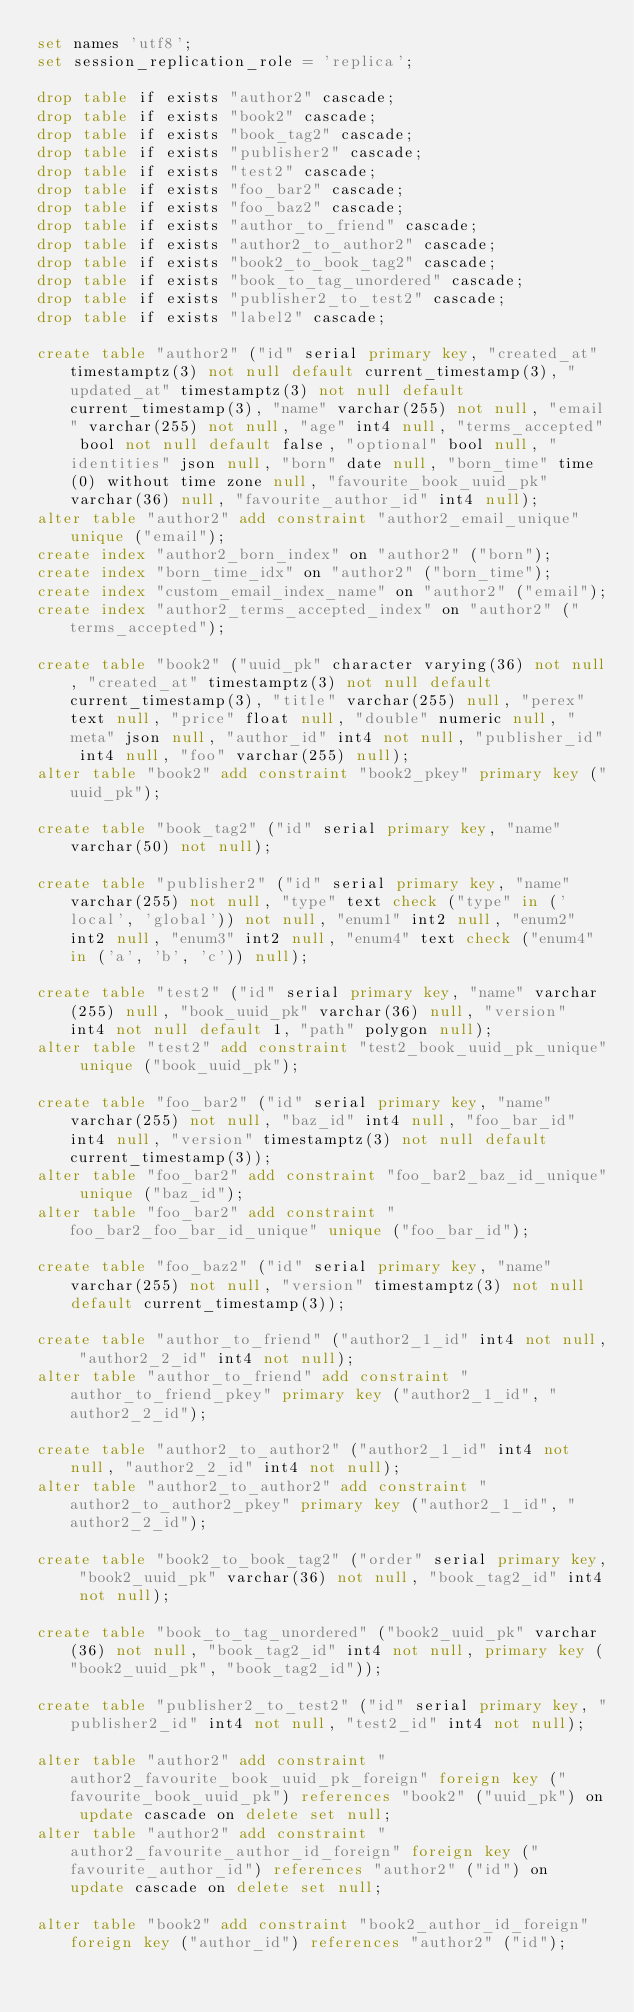<code> <loc_0><loc_0><loc_500><loc_500><_SQL_>set names 'utf8';
set session_replication_role = 'replica';

drop table if exists "author2" cascade;
drop table if exists "book2" cascade;
drop table if exists "book_tag2" cascade;
drop table if exists "publisher2" cascade;
drop table if exists "test2" cascade;
drop table if exists "foo_bar2" cascade;
drop table if exists "foo_baz2" cascade;
drop table if exists "author_to_friend" cascade;
drop table if exists "author2_to_author2" cascade;
drop table if exists "book2_to_book_tag2" cascade;
drop table if exists "book_to_tag_unordered" cascade;
drop table if exists "publisher2_to_test2" cascade;
drop table if exists "label2" cascade;

create table "author2" ("id" serial primary key, "created_at" timestamptz(3) not null default current_timestamp(3), "updated_at" timestamptz(3) not null default current_timestamp(3), "name" varchar(255) not null, "email" varchar(255) not null, "age" int4 null, "terms_accepted" bool not null default false, "optional" bool null, "identities" json null, "born" date null, "born_time" time(0) without time zone null, "favourite_book_uuid_pk" varchar(36) null, "favourite_author_id" int4 null);
alter table "author2" add constraint "author2_email_unique" unique ("email");
create index "author2_born_index" on "author2" ("born");
create index "born_time_idx" on "author2" ("born_time");
create index "custom_email_index_name" on "author2" ("email");
create index "author2_terms_accepted_index" on "author2" ("terms_accepted");

create table "book2" ("uuid_pk" character varying(36) not null, "created_at" timestamptz(3) not null default current_timestamp(3), "title" varchar(255) null, "perex" text null, "price" float null, "double" numeric null, "meta" json null, "author_id" int4 not null, "publisher_id" int4 null, "foo" varchar(255) null);
alter table "book2" add constraint "book2_pkey" primary key ("uuid_pk");

create table "book_tag2" ("id" serial primary key, "name" varchar(50) not null);

create table "publisher2" ("id" serial primary key, "name" varchar(255) not null, "type" text check ("type" in ('local', 'global')) not null, "enum1" int2 null, "enum2" int2 null, "enum3" int2 null, "enum4" text check ("enum4" in ('a', 'b', 'c')) null);

create table "test2" ("id" serial primary key, "name" varchar(255) null, "book_uuid_pk" varchar(36) null, "version" int4 not null default 1, "path" polygon null);
alter table "test2" add constraint "test2_book_uuid_pk_unique" unique ("book_uuid_pk");

create table "foo_bar2" ("id" serial primary key, "name" varchar(255) not null, "baz_id" int4 null, "foo_bar_id" int4 null, "version" timestamptz(3) not null default current_timestamp(3));
alter table "foo_bar2" add constraint "foo_bar2_baz_id_unique" unique ("baz_id");
alter table "foo_bar2" add constraint "foo_bar2_foo_bar_id_unique" unique ("foo_bar_id");

create table "foo_baz2" ("id" serial primary key, "name" varchar(255) not null, "version" timestamptz(3) not null default current_timestamp(3));

create table "author_to_friend" ("author2_1_id" int4 not null, "author2_2_id" int4 not null);
alter table "author_to_friend" add constraint "author_to_friend_pkey" primary key ("author2_1_id", "author2_2_id");

create table "author2_to_author2" ("author2_1_id" int4 not null, "author2_2_id" int4 not null);
alter table "author2_to_author2" add constraint "author2_to_author2_pkey" primary key ("author2_1_id", "author2_2_id");

create table "book2_to_book_tag2" ("order" serial primary key, "book2_uuid_pk" varchar(36) not null, "book_tag2_id" int4 not null);

create table "book_to_tag_unordered" ("book2_uuid_pk" varchar(36) not null, "book_tag2_id" int4 not null, primary key ("book2_uuid_pk", "book_tag2_id"));

create table "publisher2_to_test2" ("id" serial primary key, "publisher2_id" int4 not null, "test2_id" int4 not null);

alter table "author2" add constraint "author2_favourite_book_uuid_pk_foreign" foreign key ("favourite_book_uuid_pk") references "book2" ("uuid_pk") on update cascade on delete set null;
alter table "author2" add constraint "author2_favourite_author_id_foreign" foreign key ("favourite_author_id") references "author2" ("id") on update cascade on delete set null;

alter table "book2" add constraint "book2_author_id_foreign" foreign key ("author_id") references "author2" ("id");</code> 